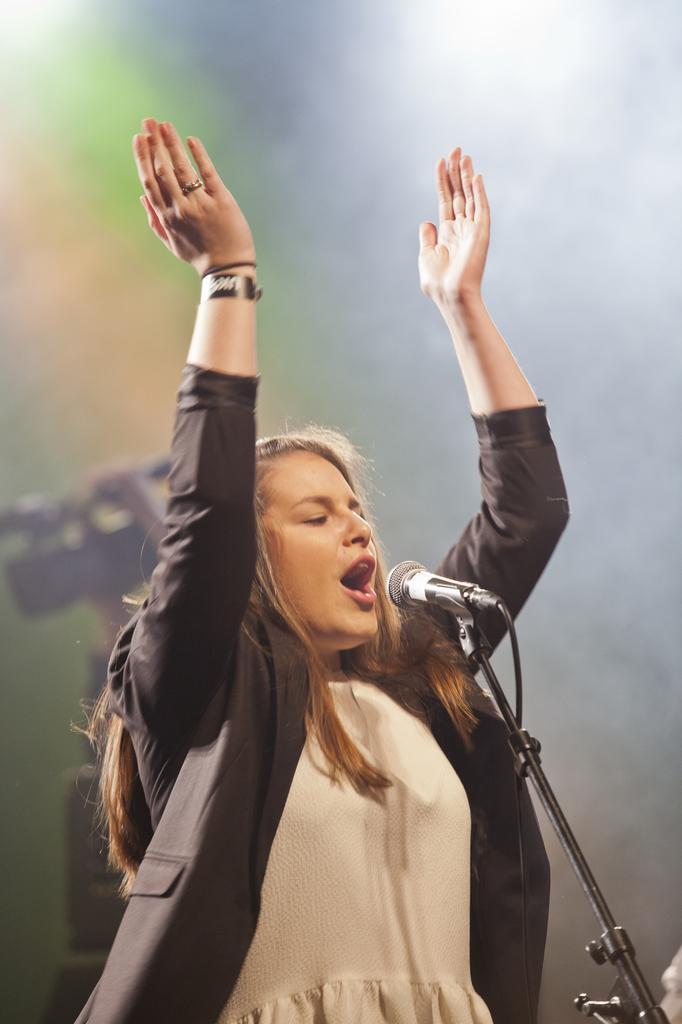Please provide a concise description of this image. In this image we can see one woman standing near the microphone and singing. There is one microphone with stand, one white object in the bottom right side corner of the image, one black object behind the woman, one person's hand behind the woman, some smoke in the background and the background is blurred. 